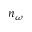<formula> <loc_0><loc_0><loc_500><loc_500>n _ { \omega }</formula> 